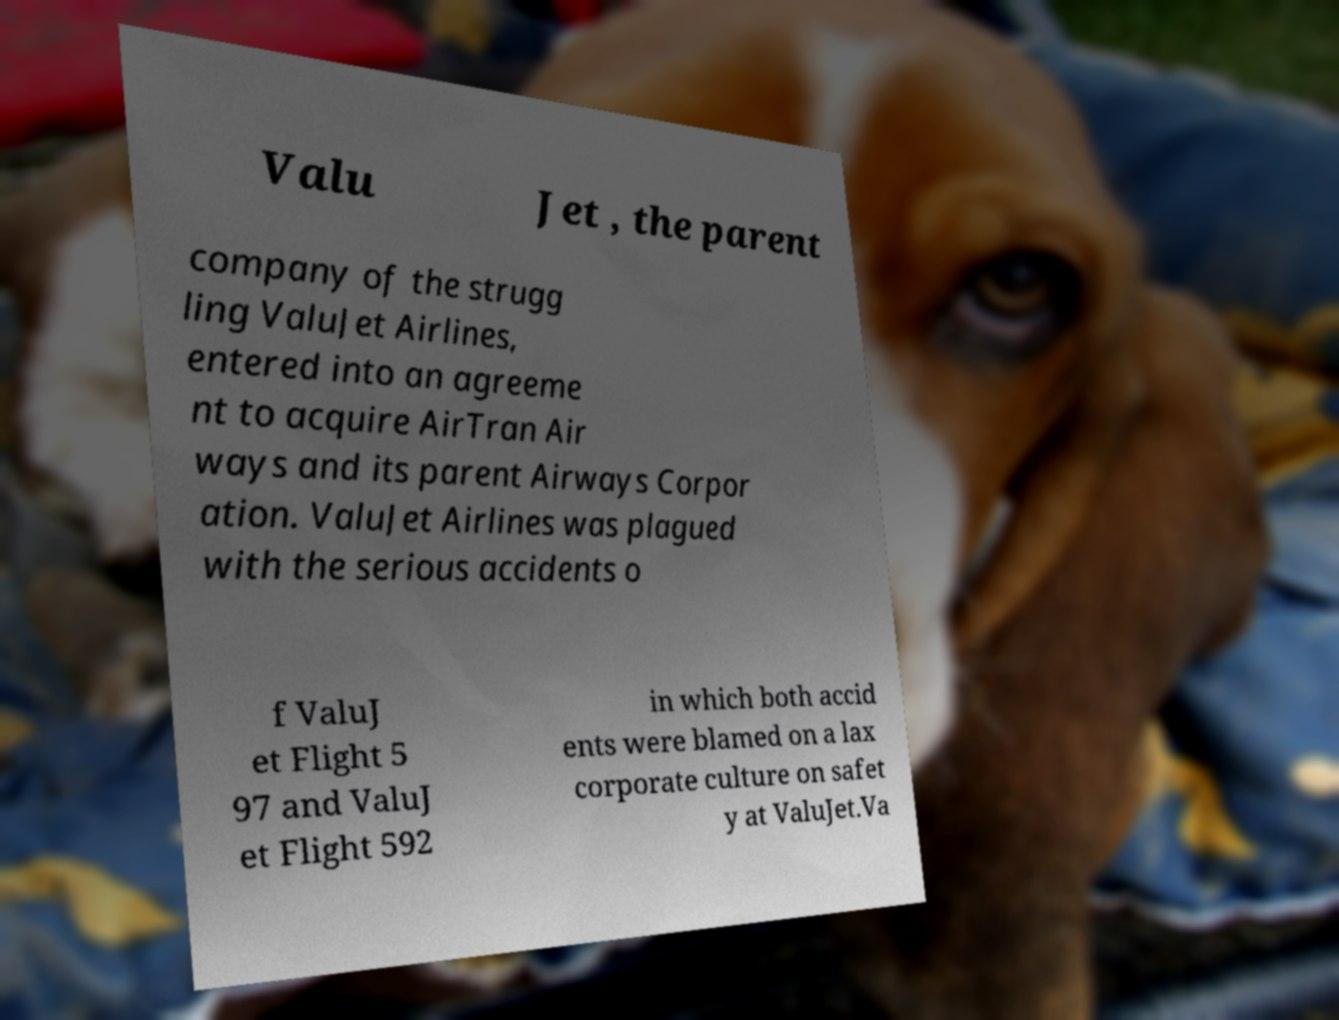I need the written content from this picture converted into text. Can you do that? Valu Jet , the parent company of the strugg ling ValuJet Airlines, entered into an agreeme nt to acquire AirTran Air ways and its parent Airways Corpor ation. ValuJet Airlines was plagued with the serious accidents o f ValuJ et Flight 5 97 and ValuJ et Flight 592 in which both accid ents were blamed on a lax corporate culture on safet y at ValuJet.Va 